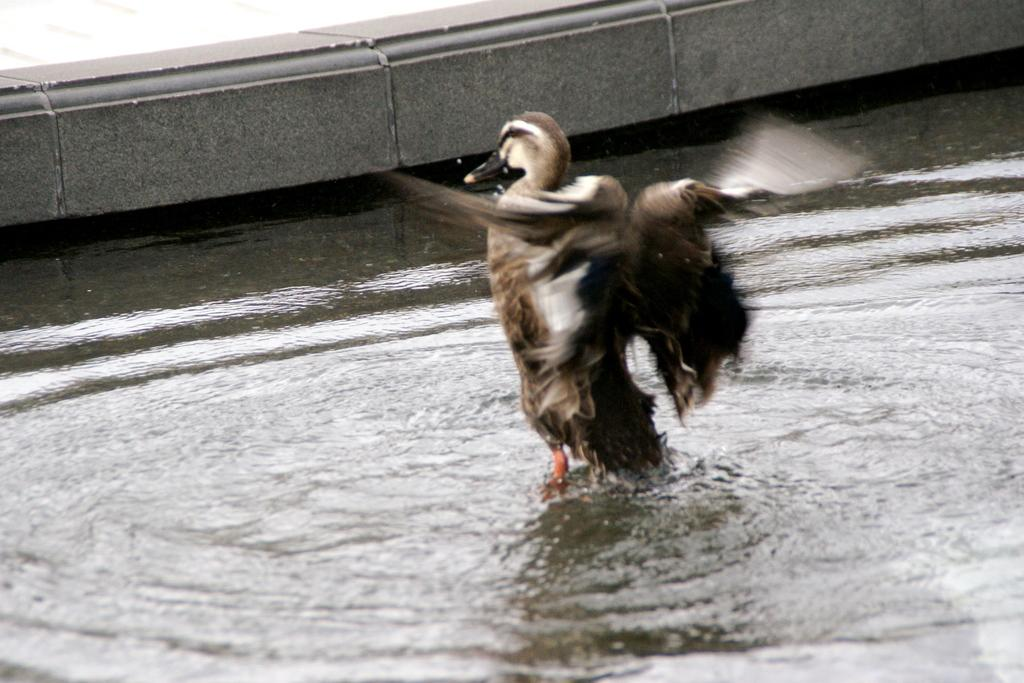What type of animal is in the image? There is a duck in the image. Where is the duck located? The duck is in the water. What type of structure can be seen in the image? There is a concrete fence in the image. What type of mountain is visible in the background of the image? There is no mountain visible in the image; it features a duck in the water and a concrete fence. 